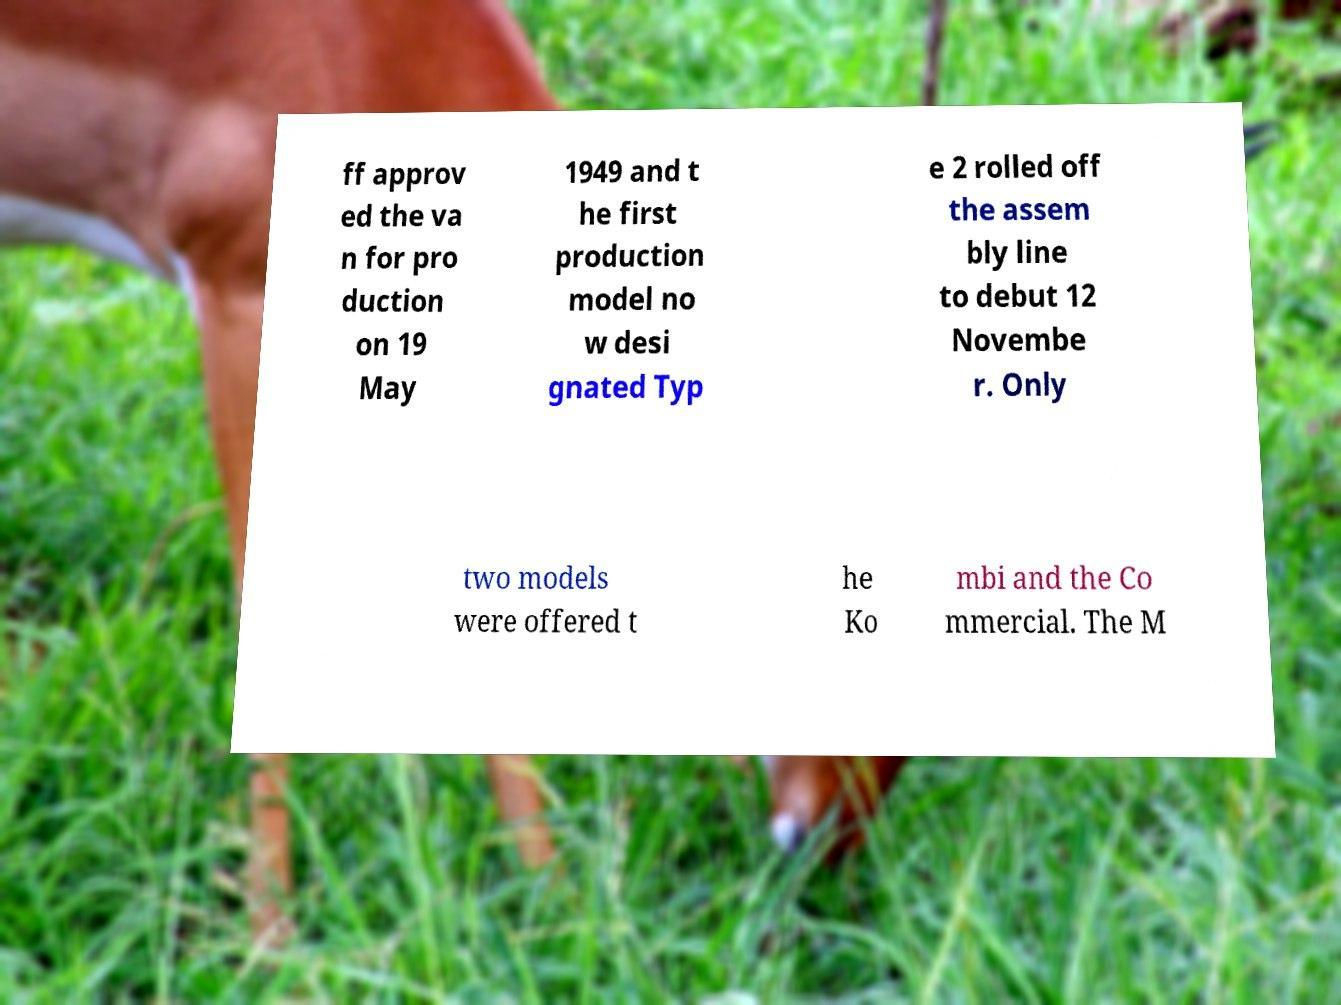I need the written content from this picture converted into text. Can you do that? ff approv ed the va n for pro duction on 19 May 1949 and t he first production model no w desi gnated Typ e 2 rolled off the assem bly line to debut 12 Novembe r. Only two models were offered t he Ko mbi and the Co mmercial. The M 